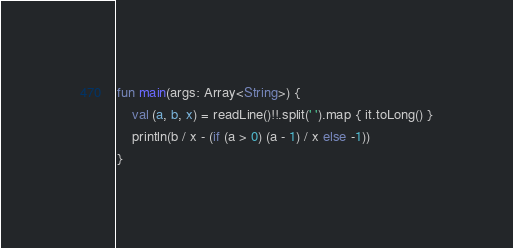Convert code to text. <code><loc_0><loc_0><loc_500><loc_500><_Kotlin_>fun main(args: Array<String>) {
    val (a, b, x) = readLine()!!.split(' ').map { it.toLong() }
    println(b / x - (if (a > 0) (a - 1) / x else -1))
}
</code> 